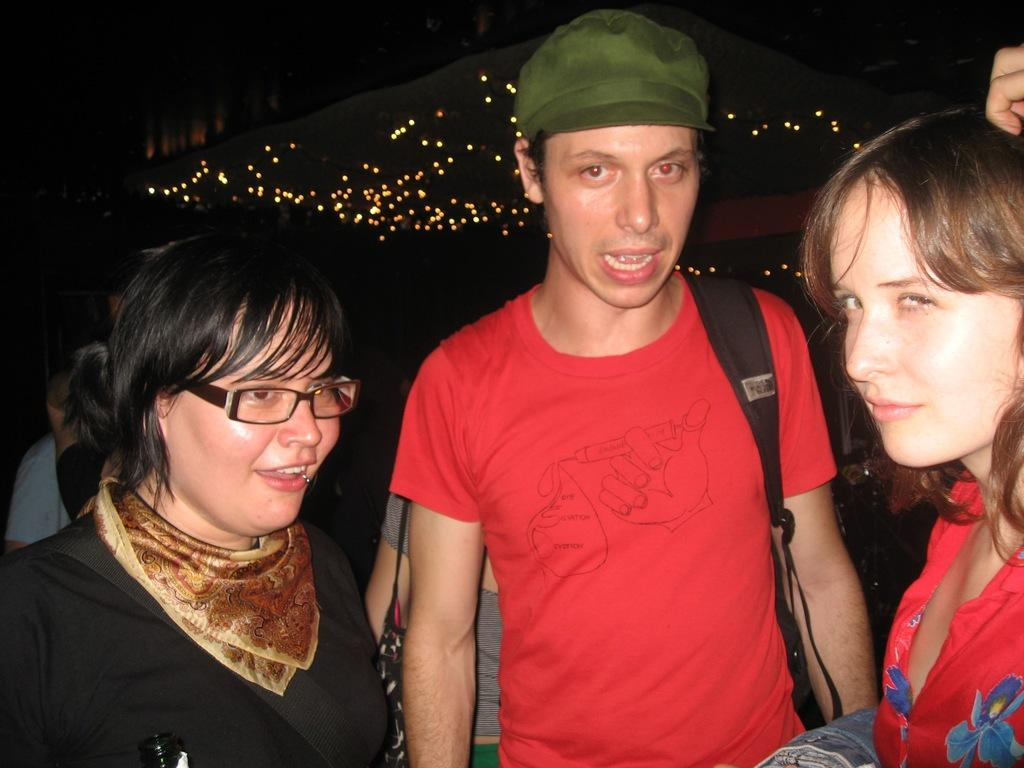What is happening in the image? There are people standing in the image. What can be seen in the background of the image? There are lights visible in the background of the image. What type of loaf is being tasted by the people in the image? There is no loaf present in the image, and the people are not shown tasting anything. 